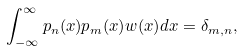Convert formula to latex. <formula><loc_0><loc_0><loc_500><loc_500>\int _ { - \infty } ^ { \infty } p _ { n } ( x ) p _ { m } ( x ) w ( x ) d x = \delta _ { m , n } ,</formula> 